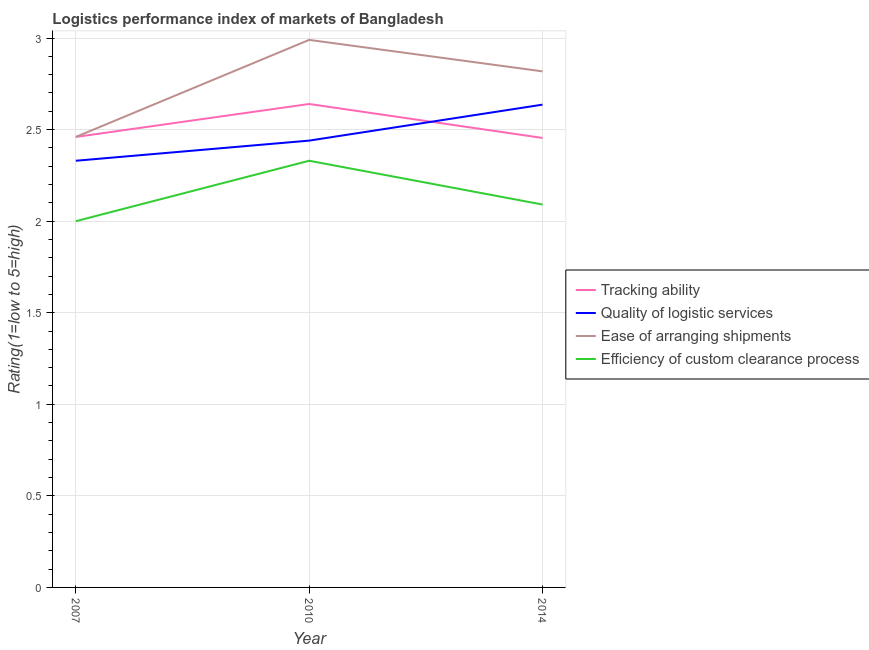How many different coloured lines are there?
Offer a very short reply. 4. Does the line corresponding to lpi rating of ease of arranging shipments intersect with the line corresponding to lpi rating of tracking ability?
Offer a terse response. Yes. Is the number of lines equal to the number of legend labels?
Make the answer very short. Yes. What is the lpi rating of tracking ability in 2014?
Your answer should be compact. 2.45. Across all years, what is the maximum lpi rating of efficiency of custom clearance process?
Your answer should be compact. 2.33. Across all years, what is the minimum lpi rating of ease of arranging shipments?
Your answer should be compact. 2.46. In which year was the lpi rating of tracking ability maximum?
Offer a terse response. 2010. In which year was the lpi rating of tracking ability minimum?
Provide a succinct answer. 2014. What is the total lpi rating of efficiency of custom clearance process in the graph?
Your response must be concise. 6.42. What is the difference between the lpi rating of quality of logistic services in 2007 and that in 2014?
Give a very brief answer. -0.31. What is the difference between the lpi rating of efficiency of custom clearance process in 2014 and the lpi rating of tracking ability in 2007?
Provide a succinct answer. -0.37. What is the average lpi rating of quality of logistic services per year?
Keep it short and to the point. 2.47. In the year 2007, what is the difference between the lpi rating of efficiency of custom clearance process and lpi rating of ease of arranging shipments?
Your response must be concise. -0.46. What is the ratio of the lpi rating of tracking ability in 2010 to that in 2014?
Your answer should be compact. 1.08. Is the lpi rating of quality of logistic services in 2007 less than that in 2014?
Offer a very short reply. Yes. What is the difference between the highest and the second highest lpi rating of quality of logistic services?
Provide a short and direct response. 0.2. What is the difference between the highest and the lowest lpi rating of quality of logistic services?
Offer a terse response. 0.31. In how many years, is the lpi rating of efficiency of custom clearance process greater than the average lpi rating of efficiency of custom clearance process taken over all years?
Your answer should be compact. 1. Is the sum of the lpi rating of quality of logistic services in 2007 and 2010 greater than the maximum lpi rating of efficiency of custom clearance process across all years?
Provide a succinct answer. Yes. Is it the case that in every year, the sum of the lpi rating of ease of arranging shipments and lpi rating of quality of logistic services is greater than the sum of lpi rating of tracking ability and lpi rating of efficiency of custom clearance process?
Your answer should be compact. Yes. Is it the case that in every year, the sum of the lpi rating of tracking ability and lpi rating of quality of logistic services is greater than the lpi rating of ease of arranging shipments?
Provide a succinct answer. Yes. Is the lpi rating of quality of logistic services strictly less than the lpi rating of efficiency of custom clearance process over the years?
Make the answer very short. No. How many lines are there?
Offer a very short reply. 4. What is the difference between two consecutive major ticks on the Y-axis?
Your response must be concise. 0.5. Are the values on the major ticks of Y-axis written in scientific E-notation?
Give a very brief answer. No. Does the graph contain any zero values?
Your response must be concise. No. Does the graph contain grids?
Offer a terse response. Yes. Where does the legend appear in the graph?
Your response must be concise. Center right. How many legend labels are there?
Keep it short and to the point. 4. How are the legend labels stacked?
Give a very brief answer. Vertical. What is the title of the graph?
Your answer should be compact. Logistics performance index of markets of Bangladesh. What is the label or title of the X-axis?
Give a very brief answer. Year. What is the label or title of the Y-axis?
Provide a succinct answer. Rating(1=low to 5=high). What is the Rating(1=low to 5=high) of Tracking ability in 2007?
Provide a succinct answer. 2.46. What is the Rating(1=low to 5=high) of Quality of logistic services in 2007?
Offer a terse response. 2.33. What is the Rating(1=low to 5=high) of Ease of arranging shipments in 2007?
Your response must be concise. 2.46. What is the Rating(1=low to 5=high) in Efficiency of custom clearance process in 2007?
Your answer should be very brief. 2. What is the Rating(1=low to 5=high) of Tracking ability in 2010?
Give a very brief answer. 2.64. What is the Rating(1=low to 5=high) in Quality of logistic services in 2010?
Give a very brief answer. 2.44. What is the Rating(1=low to 5=high) in Ease of arranging shipments in 2010?
Your answer should be very brief. 2.99. What is the Rating(1=low to 5=high) in Efficiency of custom clearance process in 2010?
Make the answer very short. 2.33. What is the Rating(1=low to 5=high) of Tracking ability in 2014?
Keep it short and to the point. 2.45. What is the Rating(1=low to 5=high) of Quality of logistic services in 2014?
Make the answer very short. 2.64. What is the Rating(1=low to 5=high) of Ease of arranging shipments in 2014?
Provide a short and direct response. 2.82. What is the Rating(1=low to 5=high) in Efficiency of custom clearance process in 2014?
Ensure brevity in your answer.  2.09. Across all years, what is the maximum Rating(1=low to 5=high) in Tracking ability?
Make the answer very short. 2.64. Across all years, what is the maximum Rating(1=low to 5=high) in Quality of logistic services?
Your answer should be compact. 2.64. Across all years, what is the maximum Rating(1=low to 5=high) of Ease of arranging shipments?
Make the answer very short. 2.99. Across all years, what is the maximum Rating(1=low to 5=high) of Efficiency of custom clearance process?
Your answer should be very brief. 2.33. Across all years, what is the minimum Rating(1=low to 5=high) in Tracking ability?
Your answer should be very brief. 2.45. Across all years, what is the minimum Rating(1=low to 5=high) in Quality of logistic services?
Your answer should be compact. 2.33. Across all years, what is the minimum Rating(1=low to 5=high) of Ease of arranging shipments?
Give a very brief answer. 2.46. What is the total Rating(1=low to 5=high) in Tracking ability in the graph?
Keep it short and to the point. 7.55. What is the total Rating(1=low to 5=high) in Quality of logistic services in the graph?
Provide a succinct answer. 7.41. What is the total Rating(1=low to 5=high) of Ease of arranging shipments in the graph?
Provide a succinct answer. 8.27. What is the total Rating(1=low to 5=high) in Efficiency of custom clearance process in the graph?
Give a very brief answer. 6.42. What is the difference between the Rating(1=low to 5=high) of Tracking ability in 2007 and that in 2010?
Your response must be concise. -0.18. What is the difference between the Rating(1=low to 5=high) of Quality of logistic services in 2007 and that in 2010?
Offer a terse response. -0.11. What is the difference between the Rating(1=low to 5=high) of Ease of arranging shipments in 2007 and that in 2010?
Your response must be concise. -0.53. What is the difference between the Rating(1=low to 5=high) in Efficiency of custom clearance process in 2007 and that in 2010?
Your answer should be very brief. -0.33. What is the difference between the Rating(1=low to 5=high) in Tracking ability in 2007 and that in 2014?
Give a very brief answer. 0.01. What is the difference between the Rating(1=low to 5=high) of Quality of logistic services in 2007 and that in 2014?
Keep it short and to the point. -0.31. What is the difference between the Rating(1=low to 5=high) in Ease of arranging shipments in 2007 and that in 2014?
Make the answer very short. -0.36. What is the difference between the Rating(1=low to 5=high) of Efficiency of custom clearance process in 2007 and that in 2014?
Ensure brevity in your answer.  -0.09. What is the difference between the Rating(1=low to 5=high) in Tracking ability in 2010 and that in 2014?
Keep it short and to the point. 0.19. What is the difference between the Rating(1=low to 5=high) of Quality of logistic services in 2010 and that in 2014?
Provide a short and direct response. -0.2. What is the difference between the Rating(1=low to 5=high) of Ease of arranging shipments in 2010 and that in 2014?
Make the answer very short. 0.17. What is the difference between the Rating(1=low to 5=high) of Efficiency of custom clearance process in 2010 and that in 2014?
Give a very brief answer. 0.24. What is the difference between the Rating(1=low to 5=high) in Tracking ability in 2007 and the Rating(1=low to 5=high) in Ease of arranging shipments in 2010?
Offer a very short reply. -0.53. What is the difference between the Rating(1=low to 5=high) of Tracking ability in 2007 and the Rating(1=low to 5=high) of Efficiency of custom clearance process in 2010?
Offer a terse response. 0.13. What is the difference between the Rating(1=low to 5=high) of Quality of logistic services in 2007 and the Rating(1=low to 5=high) of Ease of arranging shipments in 2010?
Ensure brevity in your answer.  -0.66. What is the difference between the Rating(1=low to 5=high) in Quality of logistic services in 2007 and the Rating(1=low to 5=high) in Efficiency of custom clearance process in 2010?
Give a very brief answer. 0. What is the difference between the Rating(1=low to 5=high) of Ease of arranging shipments in 2007 and the Rating(1=low to 5=high) of Efficiency of custom clearance process in 2010?
Keep it short and to the point. 0.13. What is the difference between the Rating(1=low to 5=high) in Tracking ability in 2007 and the Rating(1=low to 5=high) in Quality of logistic services in 2014?
Offer a very short reply. -0.18. What is the difference between the Rating(1=low to 5=high) of Tracking ability in 2007 and the Rating(1=low to 5=high) of Ease of arranging shipments in 2014?
Keep it short and to the point. -0.36. What is the difference between the Rating(1=low to 5=high) in Tracking ability in 2007 and the Rating(1=low to 5=high) in Efficiency of custom clearance process in 2014?
Your answer should be compact. 0.37. What is the difference between the Rating(1=low to 5=high) of Quality of logistic services in 2007 and the Rating(1=low to 5=high) of Ease of arranging shipments in 2014?
Your response must be concise. -0.49. What is the difference between the Rating(1=low to 5=high) of Quality of logistic services in 2007 and the Rating(1=low to 5=high) of Efficiency of custom clearance process in 2014?
Your response must be concise. 0.24. What is the difference between the Rating(1=low to 5=high) in Ease of arranging shipments in 2007 and the Rating(1=low to 5=high) in Efficiency of custom clearance process in 2014?
Offer a very short reply. 0.37. What is the difference between the Rating(1=low to 5=high) in Tracking ability in 2010 and the Rating(1=low to 5=high) in Quality of logistic services in 2014?
Keep it short and to the point. 0. What is the difference between the Rating(1=low to 5=high) of Tracking ability in 2010 and the Rating(1=low to 5=high) of Ease of arranging shipments in 2014?
Ensure brevity in your answer.  -0.18. What is the difference between the Rating(1=low to 5=high) in Tracking ability in 2010 and the Rating(1=low to 5=high) in Efficiency of custom clearance process in 2014?
Keep it short and to the point. 0.55. What is the difference between the Rating(1=low to 5=high) of Quality of logistic services in 2010 and the Rating(1=low to 5=high) of Ease of arranging shipments in 2014?
Ensure brevity in your answer.  -0.38. What is the difference between the Rating(1=low to 5=high) of Quality of logistic services in 2010 and the Rating(1=low to 5=high) of Efficiency of custom clearance process in 2014?
Keep it short and to the point. 0.35. What is the difference between the Rating(1=low to 5=high) in Ease of arranging shipments in 2010 and the Rating(1=low to 5=high) in Efficiency of custom clearance process in 2014?
Offer a very short reply. 0.9. What is the average Rating(1=low to 5=high) of Tracking ability per year?
Make the answer very short. 2.52. What is the average Rating(1=low to 5=high) in Quality of logistic services per year?
Your answer should be very brief. 2.47. What is the average Rating(1=low to 5=high) of Ease of arranging shipments per year?
Give a very brief answer. 2.76. What is the average Rating(1=low to 5=high) of Efficiency of custom clearance process per year?
Offer a terse response. 2.14. In the year 2007, what is the difference between the Rating(1=low to 5=high) in Tracking ability and Rating(1=low to 5=high) in Quality of logistic services?
Offer a very short reply. 0.13. In the year 2007, what is the difference between the Rating(1=low to 5=high) of Tracking ability and Rating(1=low to 5=high) of Efficiency of custom clearance process?
Give a very brief answer. 0.46. In the year 2007, what is the difference between the Rating(1=low to 5=high) in Quality of logistic services and Rating(1=low to 5=high) in Ease of arranging shipments?
Offer a very short reply. -0.13. In the year 2007, what is the difference between the Rating(1=low to 5=high) of Quality of logistic services and Rating(1=low to 5=high) of Efficiency of custom clearance process?
Make the answer very short. 0.33. In the year 2007, what is the difference between the Rating(1=low to 5=high) in Ease of arranging shipments and Rating(1=low to 5=high) in Efficiency of custom clearance process?
Offer a terse response. 0.46. In the year 2010, what is the difference between the Rating(1=low to 5=high) in Tracking ability and Rating(1=low to 5=high) in Ease of arranging shipments?
Your answer should be very brief. -0.35. In the year 2010, what is the difference between the Rating(1=low to 5=high) of Tracking ability and Rating(1=low to 5=high) of Efficiency of custom clearance process?
Provide a succinct answer. 0.31. In the year 2010, what is the difference between the Rating(1=low to 5=high) of Quality of logistic services and Rating(1=low to 5=high) of Ease of arranging shipments?
Provide a succinct answer. -0.55. In the year 2010, what is the difference between the Rating(1=low to 5=high) in Quality of logistic services and Rating(1=low to 5=high) in Efficiency of custom clearance process?
Provide a short and direct response. 0.11. In the year 2010, what is the difference between the Rating(1=low to 5=high) of Ease of arranging shipments and Rating(1=low to 5=high) of Efficiency of custom clearance process?
Give a very brief answer. 0.66. In the year 2014, what is the difference between the Rating(1=low to 5=high) in Tracking ability and Rating(1=low to 5=high) in Quality of logistic services?
Ensure brevity in your answer.  -0.18. In the year 2014, what is the difference between the Rating(1=low to 5=high) of Tracking ability and Rating(1=low to 5=high) of Ease of arranging shipments?
Your answer should be compact. -0.36. In the year 2014, what is the difference between the Rating(1=low to 5=high) of Tracking ability and Rating(1=low to 5=high) of Efficiency of custom clearance process?
Give a very brief answer. 0.36. In the year 2014, what is the difference between the Rating(1=low to 5=high) in Quality of logistic services and Rating(1=low to 5=high) in Ease of arranging shipments?
Your answer should be very brief. -0.18. In the year 2014, what is the difference between the Rating(1=low to 5=high) of Quality of logistic services and Rating(1=low to 5=high) of Efficiency of custom clearance process?
Keep it short and to the point. 0.55. In the year 2014, what is the difference between the Rating(1=low to 5=high) in Ease of arranging shipments and Rating(1=low to 5=high) in Efficiency of custom clearance process?
Give a very brief answer. 0.73. What is the ratio of the Rating(1=low to 5=high) in Tracking ability in 2007 to that in 2010?
Your answer should be very brief. 0.93. What is the ratio of the Rating(1=low to 5=high) in Quality of logistic services in 2007 to that in 2010?
Offer a very short reply. 0.95. What is the ratio of the Rating(1=low to 5=high) in Ease of arranging shipments in 2007 to that in 2010?
Your answer should be compact. 0.82. What is the ratio of the Rating(1=low to 5=high) in Efficiency of custom clearance process in 2007 to that in 2010?
Your answer should be compact. 0.86. What is the ratio of the Rating(1=low to 5=high) in Tracking ability in 2007 to that in 2014?
Provide a succinct answer. 1. What is the ratio of the Rating(1=low to 5=high) in Quality of logistic services in 2007 to that in 2014?
Your response must be concise. 0.88. What is the ratio of the Rating(1=low to 5=high) in Ease of arranging shipments in 2007 to that in 2014?
Provide a short and direct response. 0.87. What is the ratio of the Rating(1=low to 5=high) of Efficiency of custom clearance process in 2007 to that in 2014?
Offer a very short reply. 0.96. What is the ratio of the Rating(1=low to 5=high) in Tracking ability in 2010 to that in 2014?
Offer a very short reply. 1.08. What is the ratio of the Rating(1=low to 5=high) of Quality of logistic services in 2010 to that in 2014?
Ensure brevity in your answer.  0.93. What is the ratio of the Rating(1=low to 5=high) in Ease of arranging shipments in 2010 to that in 2014?
Provide a short and direct response. 1.06. What is the ratio of the Rating(1=low to 5=high) in Efficiency of custom clearance process in 2010 to that in 2014?
Give a very brief answer. 1.11. What is the difference between the highest and the second highest Rating(1=low to 5=high) in Tracking ability?
Your answer should be compact. 0.18. What is the difference between the highest and the second highest Rating(1=low to 5=high) in Quality of logistic services?
Provide a succinct answer. 0.2. What is the difference between the highest and the second highest Rating(1=low to 5=high) in Ease of arranging shipments?
Make the answer very short. 0.17. What is the difference between the highest and the second highest Rating(1=low to 5=high) of Efficiency of custom clearance process?
Ensure brevity in your answer.  0.24. What is the difference between the highest and the lowest Rating(1=low to 5=high) in Tracking ability?
Offer a terse response. 0.19. What is the difference between the highest and the lowest Rating(1=low to 5=high) in Quality of logistic services?
Your response must be concise. 0.31. What is the difference between the highest and the lowest Rating(1=low to 5=high) in Ease of arranging shipments?
Your response must be concise. 0.53. What is the difference between the highest and the lowest Rating(1=low to 5=high) in Efficiency of custom clearance process?
Keep it short and to the point. 0.33. 